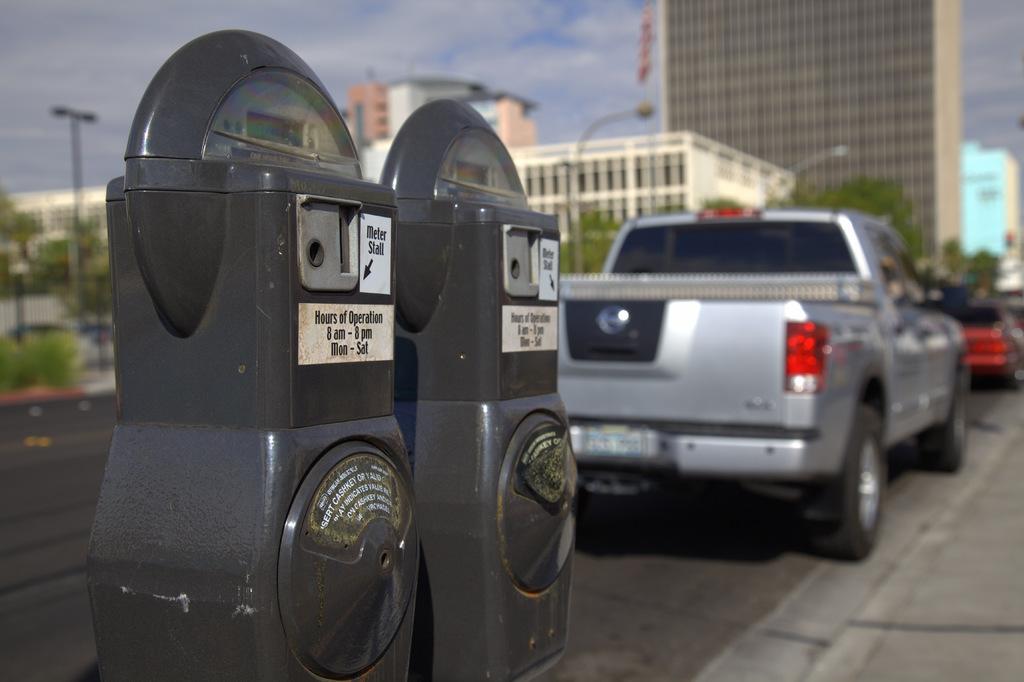What are the hours?
Ensure brevity in your answer.  8 am - 8 pm. 